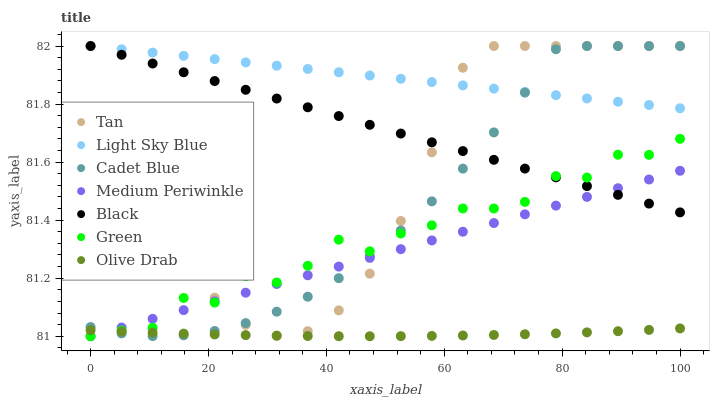Does Olive Drab have the minimum area under the curve?
Answer yes or no. Yes. Does Light Sky Blue have the maximum area under the curve?
Answer yes or no. Yes. Does Medium Periwinkle have the minimum area under the curve?
Answer yes or no. No. Does Medium Periwinkle have the maximum area under the curve?
Answer yes or no. No. Is Black the smoothest?
Answer yes or no. Yes. Is Green the roughest?
Answer yes or no. Yes. Is Medium Periwinkle the smoothest?
Answer yes or no. No. Is Medium Periwinkle the roughest?
Answer yes or no. No. Does Medium Periwinkle have the lowest value?
Answer yes or no. Yes. Does Light Sky Blue have the lowest value?
Answer yes or no. No. Does Tan have the highest value?
Answer yes or no. Yes. Does Medium Periwinkle have the highest value?
Answer yes or no. No. Is Medium Periwinkle less than Light Sky Blue?
Answer yes or no. Yes. Is Light Sky Blue greater than Olive Drab?
Answer yes or no. Yes. Does Medium Periwinkle intersect Tan?
Answer yes or no. Yes. Is Medium Periwinkle less than Tan?
Answer yes or no. No. Is Medium Periwinkle greater than Tan?
Answer yes or no. No. Does Medium Periwinkle intersect Light Sky Blue?
Answer yes or no. No. 